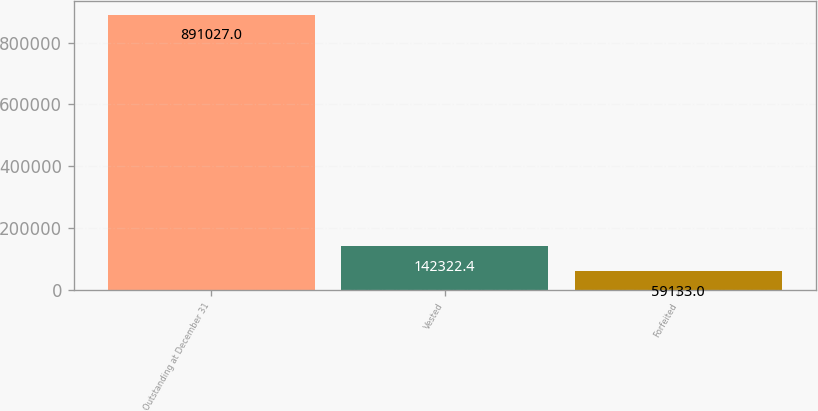<chart> <loc_0><loc_0><loc_500><loc_500><bar_chart><fcel>Outstanding at December 31<fcel>Vested<fcel>Forfeited<nl><fcel>891027<fcel>142322<fcel>59133<nl></chart> 